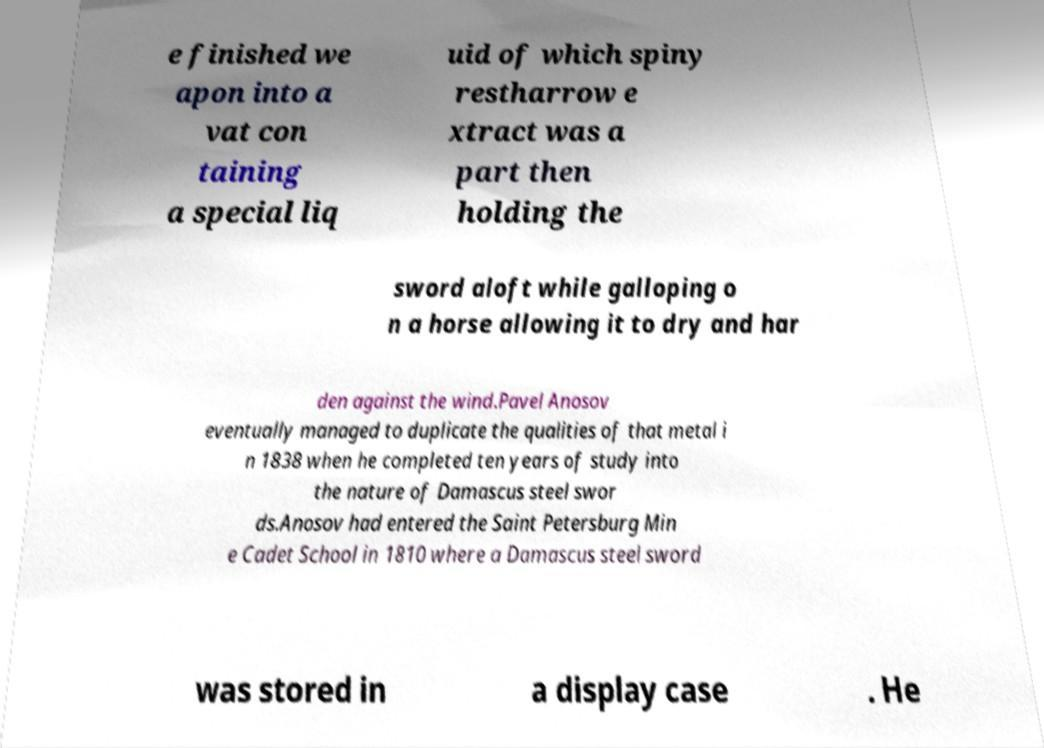Can you read and provide the text displayed in the image?This photo seems to have some interesting text. Can you extract and type it out for me? e finished we apon into a vat con taining a special liq uid of which spiny restharrow e xtract was a part then holding the sword aloft while galloping o n a horse allowing it to dry and har den against the wind.Pavel Anosov eventually managed to duplicate the qualities of that metal i n 1838 when he completed ten years of study into the nature of Damascus steel swor ds.Anosov had entered the Saint Petersburg Min e Cadet School in 1810 where a Damascus steel sword was stored in a display case . He 